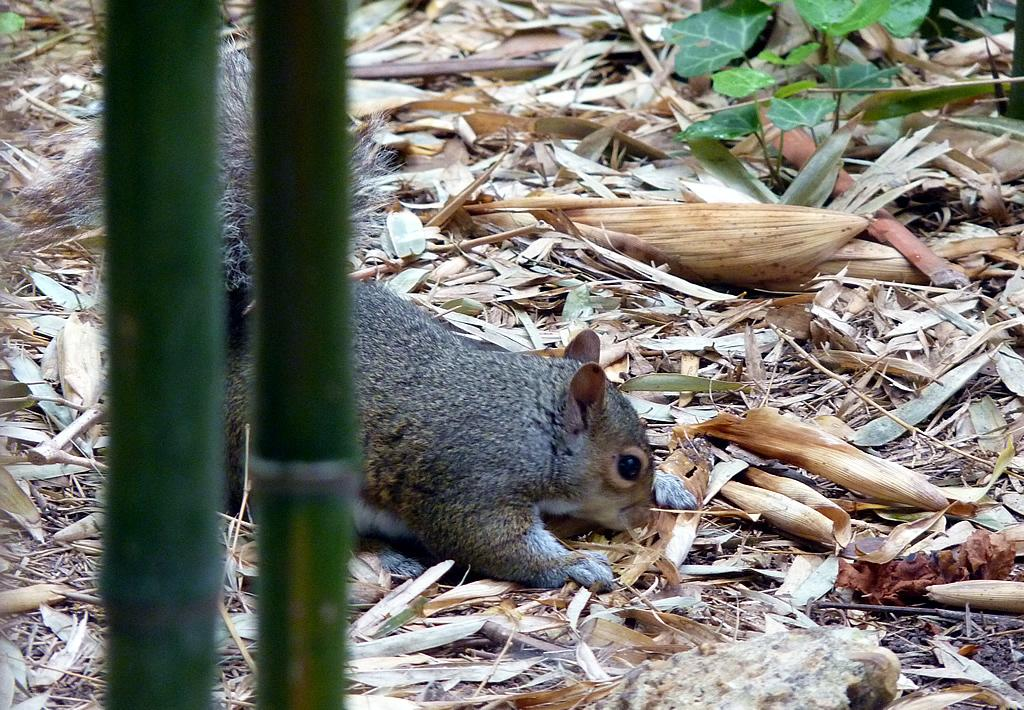What type of animal is in the image? There is a squirrel in the image. What is the squirrel standing on in the image? The squirrel is standing on land in the image. What is covering the land in the image? The land is covered with dry straws in the image. What type of operation is the squirrel performing in the image? There is no indication in the image that the squirrel is performing any operation. How does the squirrel handle the rainstorm in the image? There is no rainstorm present in the image; it features a squirrel standing on land covered with dry straws. 